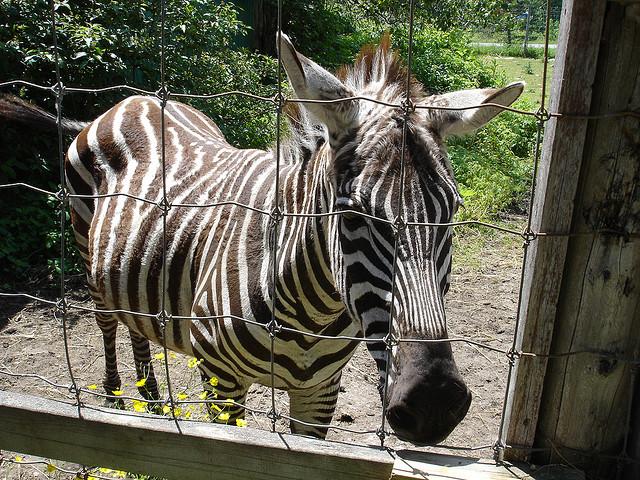Where is the zebra confined?
Write a very short answer. Zoo. Why are the zebras looking at the camera?
Give a very brief answer. Curiosity. What is in front of the zebra?
Be succinct. Fence. Does the zebra have stripes on his nose?
Quick response, please. No. What is the zebra doing?
Short answer required. Standing. 